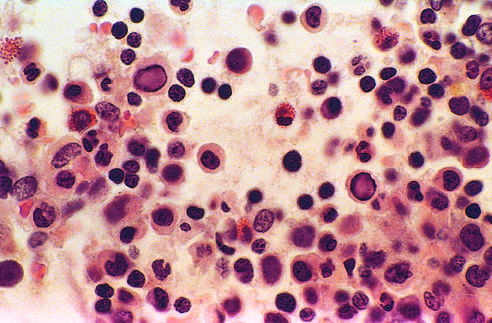how is bone marrow from an infant infected?
Answer the question using a single word or phrase. With parvovirus b19 